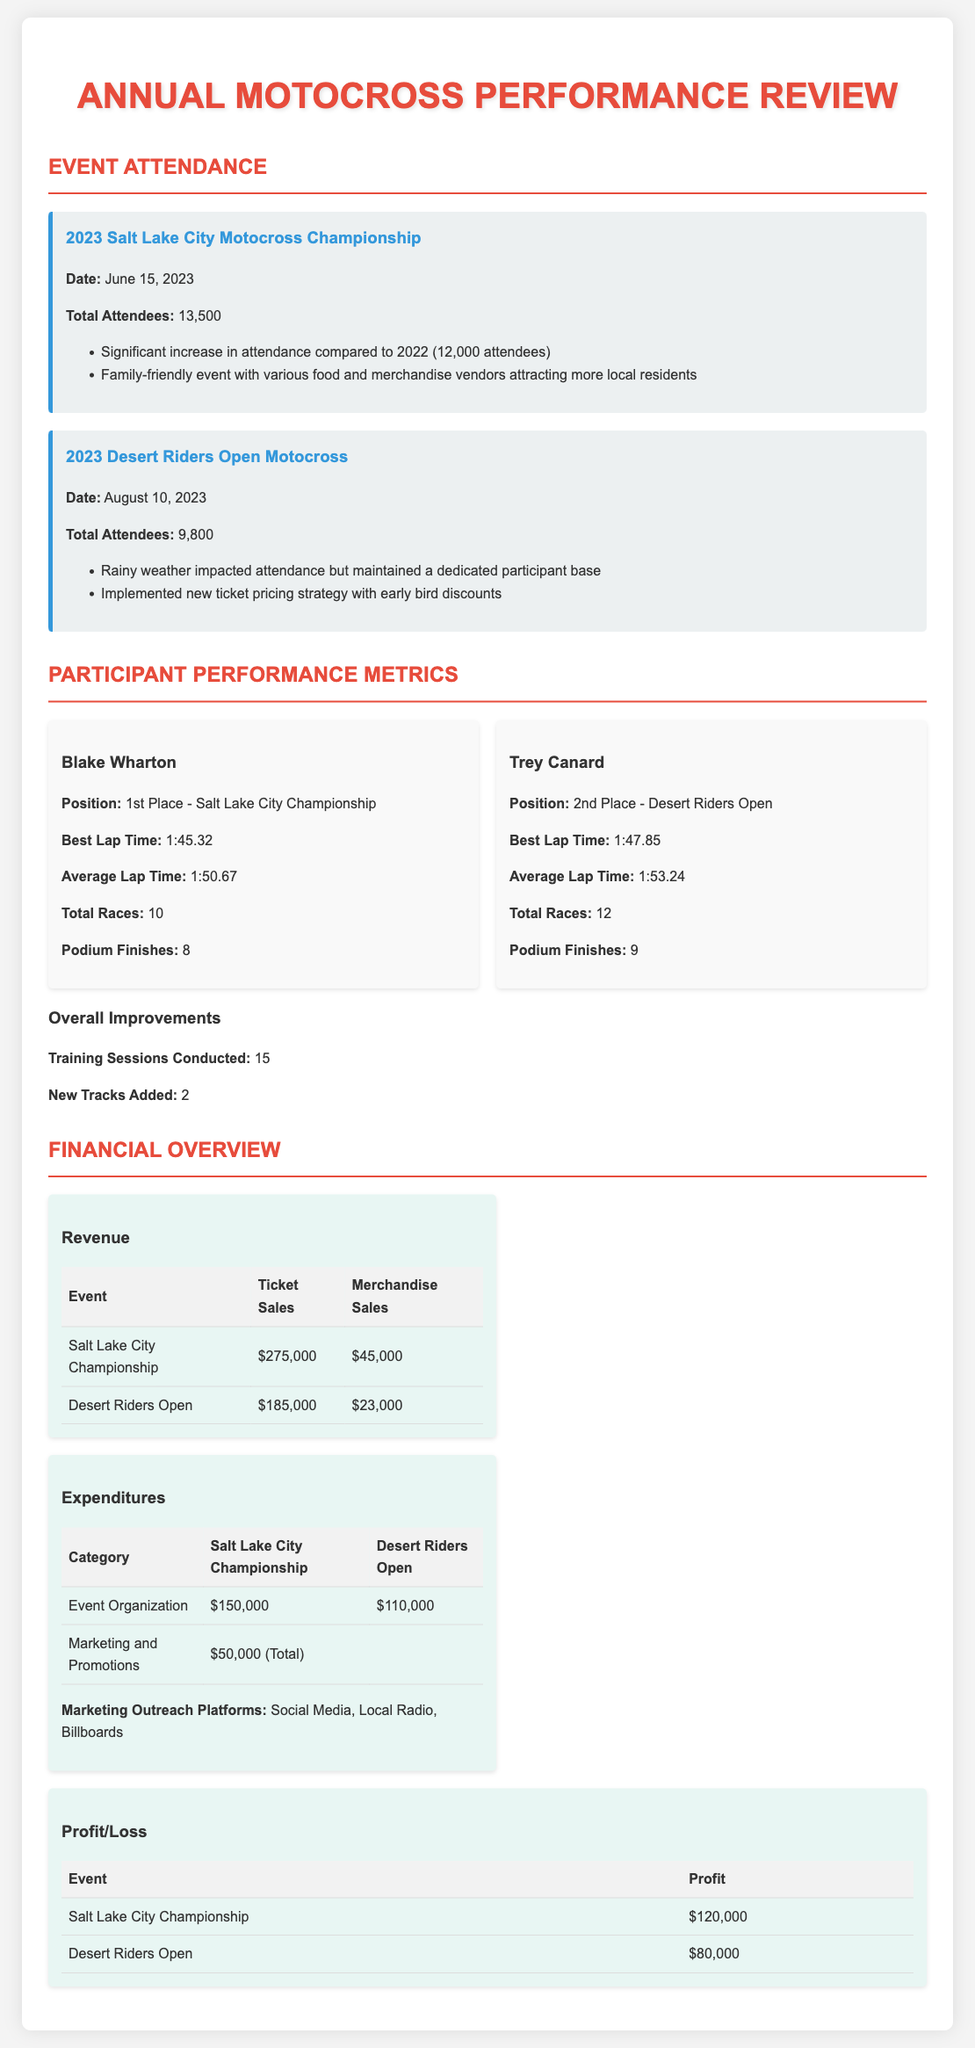What was the total attendance for the Salt Lake City Championship? The document specifies the total attendees for the Salt Lake City Championship as 13,500.
Answer: 13,500 What is Blake Wharton's best lap time? Blake Wharton's best lap time, as stated in the document, is 1:45.32.
Answer: 1:45.32 How many training sessions were conducted in total? The document indicates that there were 15 training sessions conducted overall.
Answer: 15 What is the profit for the Desert Riders Open? The profit for the Desert Riders Open, as recorded in the document, is $80,000.
Answer: $80,000 What percentage increase in attendance was noted for the Salt Lake City Championship compared to 2022? The document notes a significant increase in attendance in 2023 compared to 2022, from 12,000 to 13,500 attendees. The increase is calculated as (13,500 - 12,000) / 12,000 * 100 = 12.5%.
Answer: 12.5% What was the date of the Desert Riders Open? The document states that the Desert Riders Open took place on August 10, 2023.
Answer: August 10, 2023 How many events were there in total documented? The document details two events, the Salt Lake City Championship and the Desert Riders Open, reflecting a total of two events.
Answer: 2 What marketing outreach platforms were utilized? The document lists Social Media, Local Radio, and Billboards as the marketing outreach platforms used.
Answer: Social Media, Local Radio, Billboards 